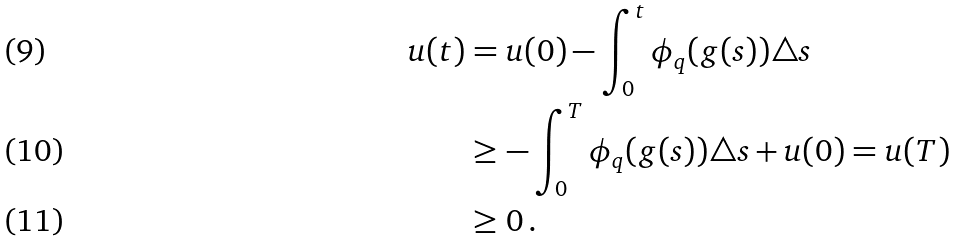Convert formula to latex. <formula><loc_0><loc_0><loc_500><loc_500>u ( t ) & = u ( 0 ) - \int _ { 0 } ^ { t } \phi _ { q } ( g ( s ) ) \triangle s \\ & \geq - \int _ { 0 } ^ { T } \phi _ { q } ( g ( s ) ) \triangle s + u ( 0 ) = u ( T ) \\ & \geq 0 \, .</formula> 